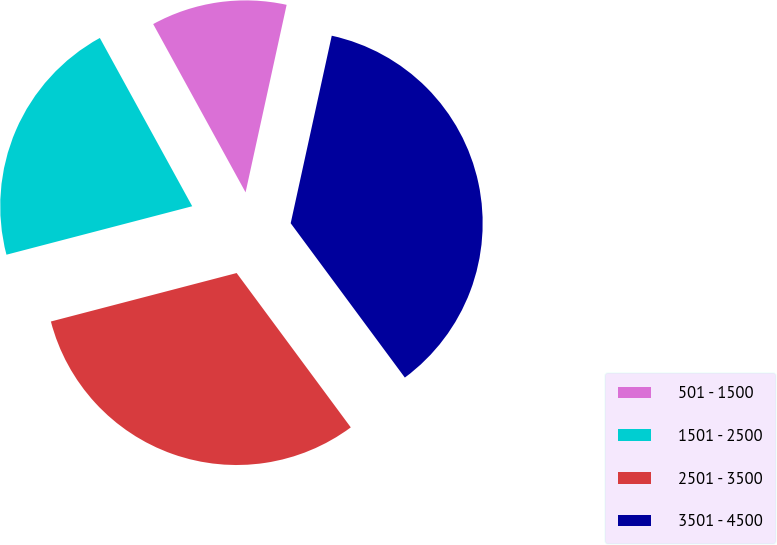Convert chart to OTSL. <chart><loc_0><loc_0><loc_500><loc_500><pie_chart><fcel>501 - 1500<fcel>1501 - 2500<fcel>2501 - 3500<fcel>3501 - 4500<nl><fcel>11.42%<fcel>21.07%<fcel>31.07%<fcel>36.43%<nl></chart> 